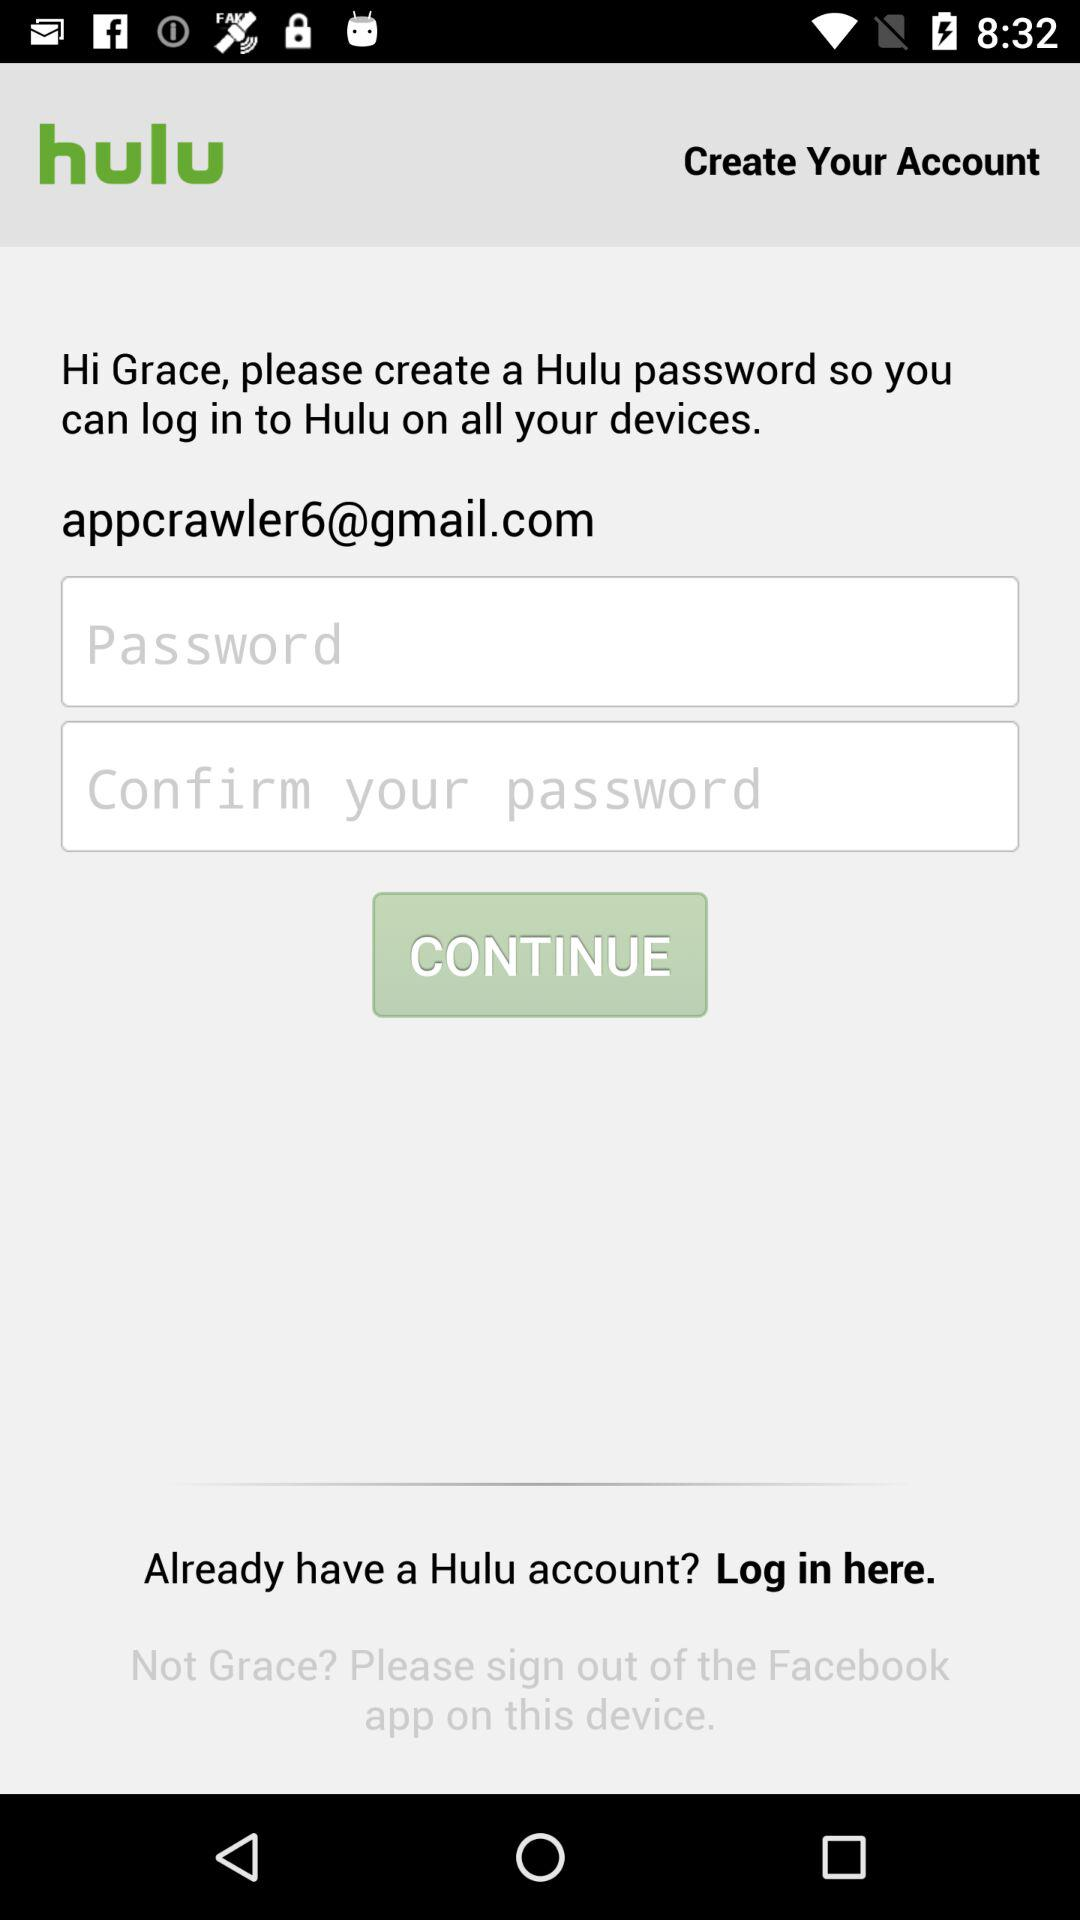What is the email address? The email address is appcrawler6@gmail.com. 